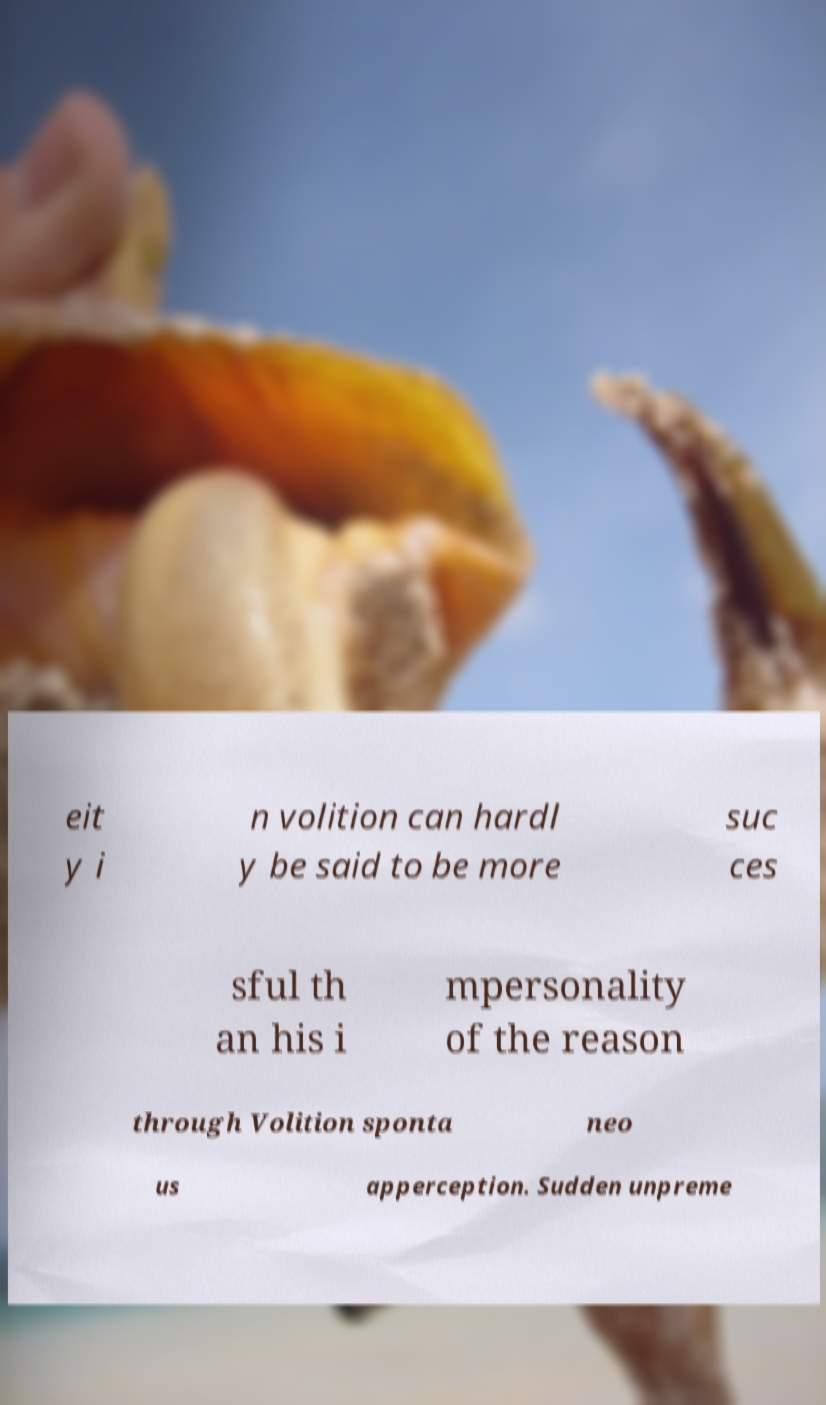What messages or text are displayed in this image? I need them in a readable, typed format. eit y i n volition can hardl y be said to be more suc ces sful th an his i mpersonality of the reason through Volition sponta neo us apperception. Sudden unpreme 